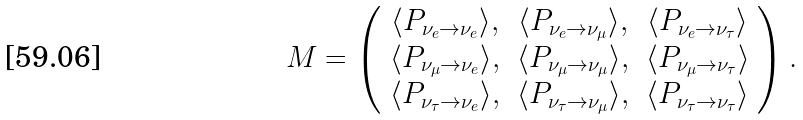<formula> <loc_0><loc_0><loc_500><loc_500>M = \left ( \begin{array} { c c c } \langle P _ { \nu _ { e } \to \nu _ { e } } \rangle , & \langle P _ { \nu _ { e } \to \nu _ { \mu } } \rangle , & \langle P _ { \nu _ { e } \to \nu _ { \tau } } \rangle \\ \langle P _ { \nu _ { \mu } \to \nu _ { e } } \rangle , & \langle P _ { \nu _ { \mu } \to \nu _ { \mu } } \rangle , & \langle P _ { \nu _ { \mu } \to \nu _ { \tau } } \rangle \\ \langle P _ { \nu _ { \tau } \to \nu _ { e } } \rangle , & \langle P _ { \nu _ { \tau } \to \nu _ { \mu } } \rangle , & \langle P _ { \nu _ { \tau } \to \nu _ { \tau } } \rangle \end{array} \right ) .</formula> 